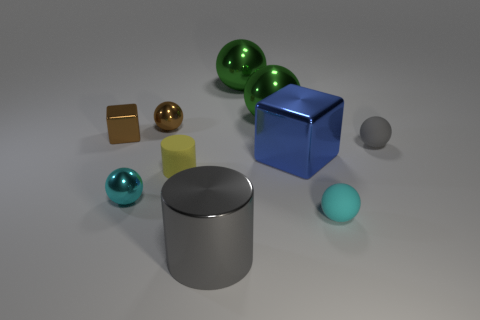What number of other things are the same size as the cyan rubber ball?
Ensure brevity in your answer.  5. There is a shiny thing that is both behind the big cylinder and in front of the large blue cube; how big is it?
Your answer should be very brief. Small. How many rubber objects are the same shape as the cyan metallic object?
Offer a terse response. 2. What material is the large cylinder?
Give a very brief answer. Metal. Is the shape of the tiny yellow object the same as the big gray object?
Your answer should be compact. Yes. Are there any gray blocks made of the same material as the gray cylinder?
Offer a very short reply. No. There is a tiny object that is in front of the blue block and right of the gray metallic cylinder; what is its color?
Give a very brief answer. Cyan. There is a small cyan ball that is on the left side of the large blue block; what material is it?
Offer a terse response. Metal. Is there a big green thing of the same shape as the tiny gray object?
Your answer should be compact. Yes. How many other objects are the same shape as the tiny cyan metal thing?
Your answer should be compact. 5. 